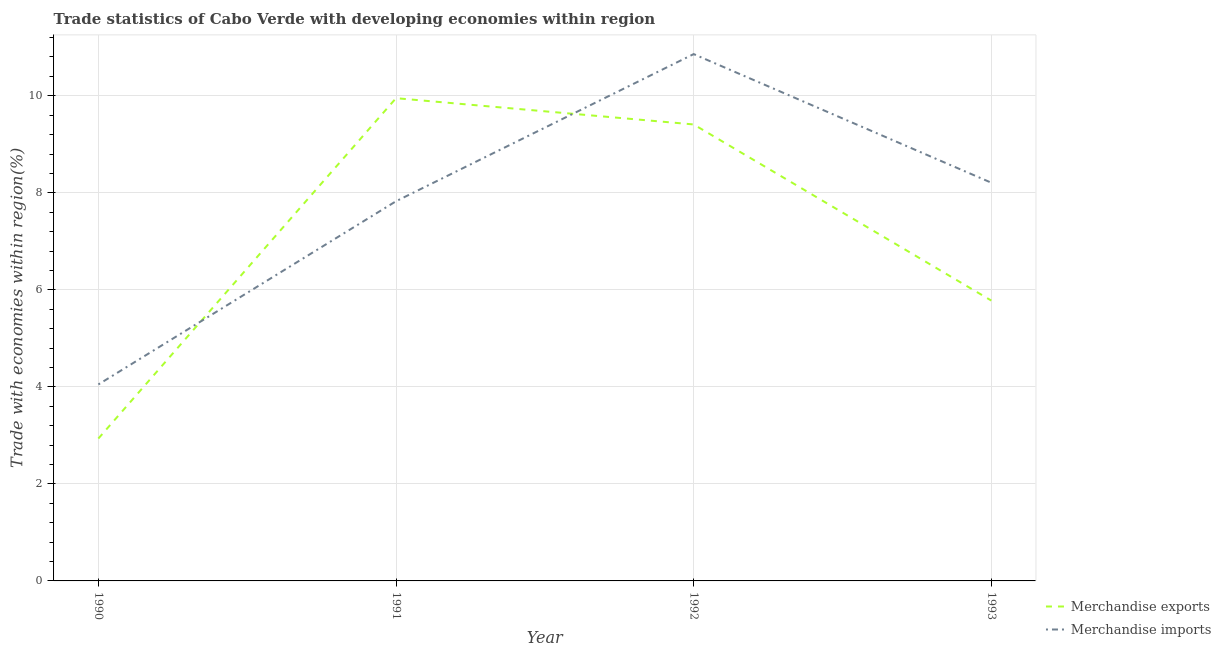How many different coloured lines are there?
Give a very brief answer. 2. Does the line corresponding to merchandise imports intersect with the line corresponding to merchandise exports?
Ensure brevity in your answer.  Yes. What is the merchandise exports in 1993?
Keep it short and to the point. 5.78. Across all years, what is the maximum merchandise imports?
Make the answer very short. 10.86. Across all years, what is the minimum merchandise exports?
Make the answer very short. 2.93. What is the total merchandise exports in the graph?
Your answer should be very brief. 28.07. What is the difference between the merchandise exports in 1990 and that in 1991?
Provide a succinct answer. -7.02. What is the difference between the merchandise imports in 1991 and the merchandise exports in 1992?
Provide a short and direct response. -1.58. What is the average merchandise imports per year?
Keep it short and to the point. 7.74. In the year 1990, what is the difference between the merchandise imports and merchandise exports?
Offer a terse response. 1.12. What is the ratio of the merchandise exports in 1990 to that in 1992?
Provide a short and direct response. 0.31. What is the difference between the highest and the second highest merchandise exports?
Offer a terse response. 0.54. What is the difference between the highest and the lowest merchandise exports?
Your response must be concise. 7.02. In how many years, is the merchandise imports greater than the average merchandise imports taken over all years?
Your answer should be compact. 3. Is the merchandise imports strictly greater than the merchandise exports over the years?
Offer a terse response. No. How many lines are there?
Make the answer very short. 2. What is the difference between two consecutive major ticks on the Y-axis?
Offer a very short reply. 2. Are the values on the major ticks of Y-axis written in scientific E-notation?
Provide a short and direct response. No. How are the legend labels stacked?
Keep it short and to the point. Vertical. What is the title of the graph?
Provide a succinct answer. Trade statistics of Cabo Verde with developing economies within region. What is the label or title of the X-axis?
Your answer should be compact. Year. What is the label or title of the Y-axis?
Give a very brief answer. Trade with economies within region(%). What is the Trade with economies within region(%) in Merchandise exports in 1990?
Give a very brief answer. 2.93. What is the Trade with economies within region(%) in Merchandise imports in 1990?
Make the answer very short. 4.05. What is the Trade with economies within region(%) of Merchandise exports in 1991?
Offer a terse response. 9.95. What is the Trade with economies within region(%) of Merchandise imports in 1991?
Make the answer very short. 7.83. What is the Trade with economies within region(%) in Merchandise exports in 1992?
Your answer should be compact. 9.41. What is the Trade with economies within region(%) of Merchandise imports in 1992?
Give a very brief answer. 10.86. What is the Trade with economies within region(%) of Merchandise exports in 1993?
Keep it short and to the point. 5.78. What is the Trade with economies within region(%) of Merchandise imports in 1993?
Provide a succinct answer. 8.21. Across all years, what is the maximum Trade with economies within region(%) in Merchandise exports?
Keep it short and to the point. 9.95. Across all years, what is the maximum Trade with economies within region(%) in Merchandise imports?
Make the answer very short. 10.86. Across all years, what is the minimum Trade with economies within region(%) in Merchandise exports?
Offer a terse response. 2.93. Across all years, what is the minimum Trade with economies within region(%) of Merchandise imports?
Make the answer very short. 4.05. What is the total Trade with economies within region(%) of Merchandise exports in the graph?
Make the answer very short. 28.07. What is the total Trade with economies within region(%) in Merchandise imports in the graph?
Provide a short and direct response. 30.94. What is the difference between the Trade with economies within region(%) in Merchandise exports in 1990 and that in 1991?
Give a very brief answer. -7.02. What is the difference between the Trade with economies within region(%) in Merchandise imports in 1990 and that in 1991?
Your response must be concise. -3.78. What is the difference between the Trade with economies within region(%) of Merchandise exports in 1990 and that in 1992?
Your answer should be compact. -6.47. What is the difference between the Trade with economies within region(%) in Merchandise imports in 1990 and that in 1992?
Your answer should be very brief. -6.81. What is the difference between the Trade with economies within region(%) in Merchandise exports in 1990 and that in 1993?
Ensure brevity in your answer.  -2.84. What is the difference between the Trade with economies within region(%) in Merchandise imports in 1990 and that in 1993?
Provide a succinct answer. -4.16. What is the difference between the Trade with economies within region(%) in Merchandise exports in 1991 and that in 1992?
Provide a short and direct response. 0.54. What is the difference between the Trade with economies within region(%) in Merchandise imports in 1991 and that in 1992?
Ensure brevity in your answer.  -3.03. What is the difference between the Trade with economies within region(%) of Merchandise exports in 1991 and that in 1993?
Your answer should be compact. 4.17. What is the difference between the Trade with economies within region(%) in Merchandise imports in 1991 and that in 1993?
Offer a very short reply. -0.38. What is the difference between the Trade with economies within region(%) of Merchandise exports in 1992 and that in 1993?
Offer a very short reply. 3.63. What is the difference between the Trade with economies within region(%) in Merchandise imports in 1992 and that in 1993?
Keep it short and to the point. 2.65. What is the difference between the Trade with economies within region(%) in Merchandise exports in 1990 and the Trade with economies within region(%) in Merchandise imports in 1991?
Offer a terse response. -4.89. What is the difference between the Trade with economies within region(%) in Merchandise exports in 1990 and the Trade with economies within region(%) in Merchandise imports in 1992?
Your response must be concise. -7.92. What is the difference between the Trade with economies within region(%) of Merchandise exports in 1990 and the Trade with economies within region(%) of Merchandise imports in 1993?
Make the answer very short. -5.27. What is the difference between the Trade with economies within region(%) of Merchandise exports in 1991 and the Trade with economies within region(%) of Merchandise imports in 1992?
Give a very brief answer. -0.91. What is the difference between the Trade with economies within region(%) in Merchandise exports in 1991 and the Trade with economies within region(%) in Merchandise imports in 1993?
Offer a very short reply. 1.74. What is the difference between the Trade with economies within region(%) in Merchandise exports in 1992 and the Trade with economies within region(%) in Merchandise imports in 1993?
Give a very brief answer. 1.2. What is the average Trade with economies within region(%) in Merchandise exports per year?
Make the answer very short. 7.02. What is the average Trade with economies within region(%) of Merchandise imports per year?
Your response must be concise. 7.74. In the year 1990, what is the difference between the Trade with economies within region(%) in Merchandise exports and Trade with economies within region(%) in Merchandise imports?
Your response must be concise. -1.11. In the year 1991, what is the difference between the Trade with economies within region(%) of Merchandise exports and Trade with economies within region(%) of Merchandise imports?
Offer a terse response. 2.12. In the year 1992, what is the difference between the Trade with economies within region(%) of Merchandise exports and Trade with economies within region(%) of Merchandise imports?
Your answer should be very brief. -1.45. In the year 1993, what is the difference between the Trade with economies within region(%) in Merchandise exports and Trade with economies within region(%) in Merchandise imports?
Provide a succinct answer. -2.43. What is the ratio of the Trade with economies within region(%) of Merchandise exports in 1990 to that in 1991?
Make the answer very short. 0.29. What is the ratio of the Trade with economies within region(%) in Merchandise imports in 1990 to that in 1991?
Ensure brevity in your answer.  0.52. What is the ratio of the Trade with economies within region(%) in Merchandise exports in 1990 to that in 1992?
Offer a very short reply. 0.31. What is the ratio of the Trade with economies within region(%) of Merchandise imports in 1990 to that in 1992?
Your answer should be very brief. 0.37. What is the ratio of the Trade with economies within region(%) of Merchandise exports in 1990 to that in 1993?
Your answer should be very brief. 0.51. What is the ratio of the Trade with economies within region(%) in Merchandise imports in 1990 to that in 1993?
Ensure brevity in your answer.  0.49. What is the ratio of the Trade with economies within region(%) of Merchandise exports in 1991 to that in 1992?
Offer a very short reply. 1.06. What is the ratio of the Trade with economies within region(%) of Merchandise imports in 1991 to that in 1992?
Your answer should be very brief. 0.72. What is the ratio of the Trade with economies within region(%) of Merchandise exports in 1991 to that in 1993?
Make the answer very short. 1.72. What is the ratio of the Trade with economies within region(%) of Merchandise imports in 1991 to that in 1993?
Provide a succinct answer. 0.95. What is the ratio of the Trade with economies within region(%) of Merchandise exports in 1992 to that in 1993?
Keep it short and to the point. 1.63. What is the ratio of the Trade with economies within region(%) of Merchandise imports in 1992 to that in 1993?
Offer a very short reply. 1.32. What is the difference between the highest and the second highest Trade with economies within region(%) of Merchandise exports?
Make the answer very short. 0.54. What is the difference between the highest and the second highest Trade with economies within region(%) of Merchandise imports?
Offer a very short reply. 2.65. What is the difference between the highest and the lowest Trade with economies within region(%) of Merchandise exports?
Your answer should be very brief. 7.02. What is the difference between the highest and the lowest Trade with economies within region(%) of Merchandise imports?
Provide a short and direct response. 6.81. 